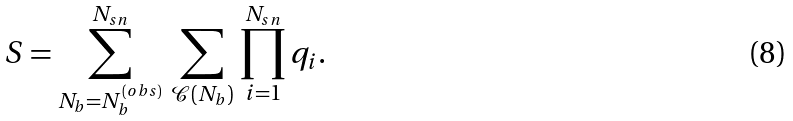Convert formula to latex. <formula><loc_0><loc_0><loc_500><loc_500>S = \sum _ { N _ { b } = N _ { b } ^ { ( o b s ) } } ^ { N _ { s n } } \, \sum _ { \mathcal { C } ( N _ { b } ) } \, \prod _ { i = 1 } ^ { N _ { s n } } q _ { i } .</formula> 